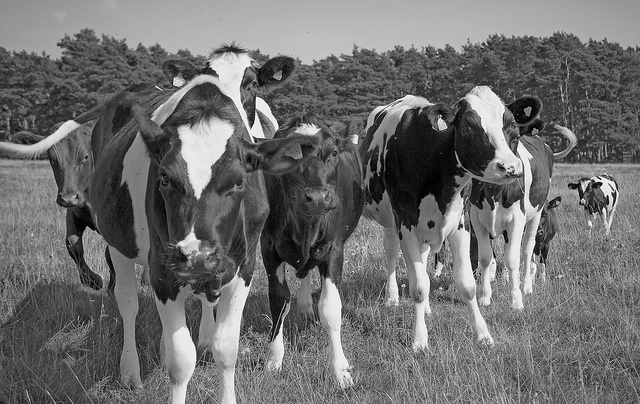Describe the objects in this image and their specific colors. I can see cow in gray, black, and gainsboro tones, cow in gray, black, lightgray, and darkgray tones, cow in gray, black, lightgray, and darkgray tones, cow in gray, lightgray, darkgray, and black tones, and cow in gray, black, and lightgray tones in this image. 